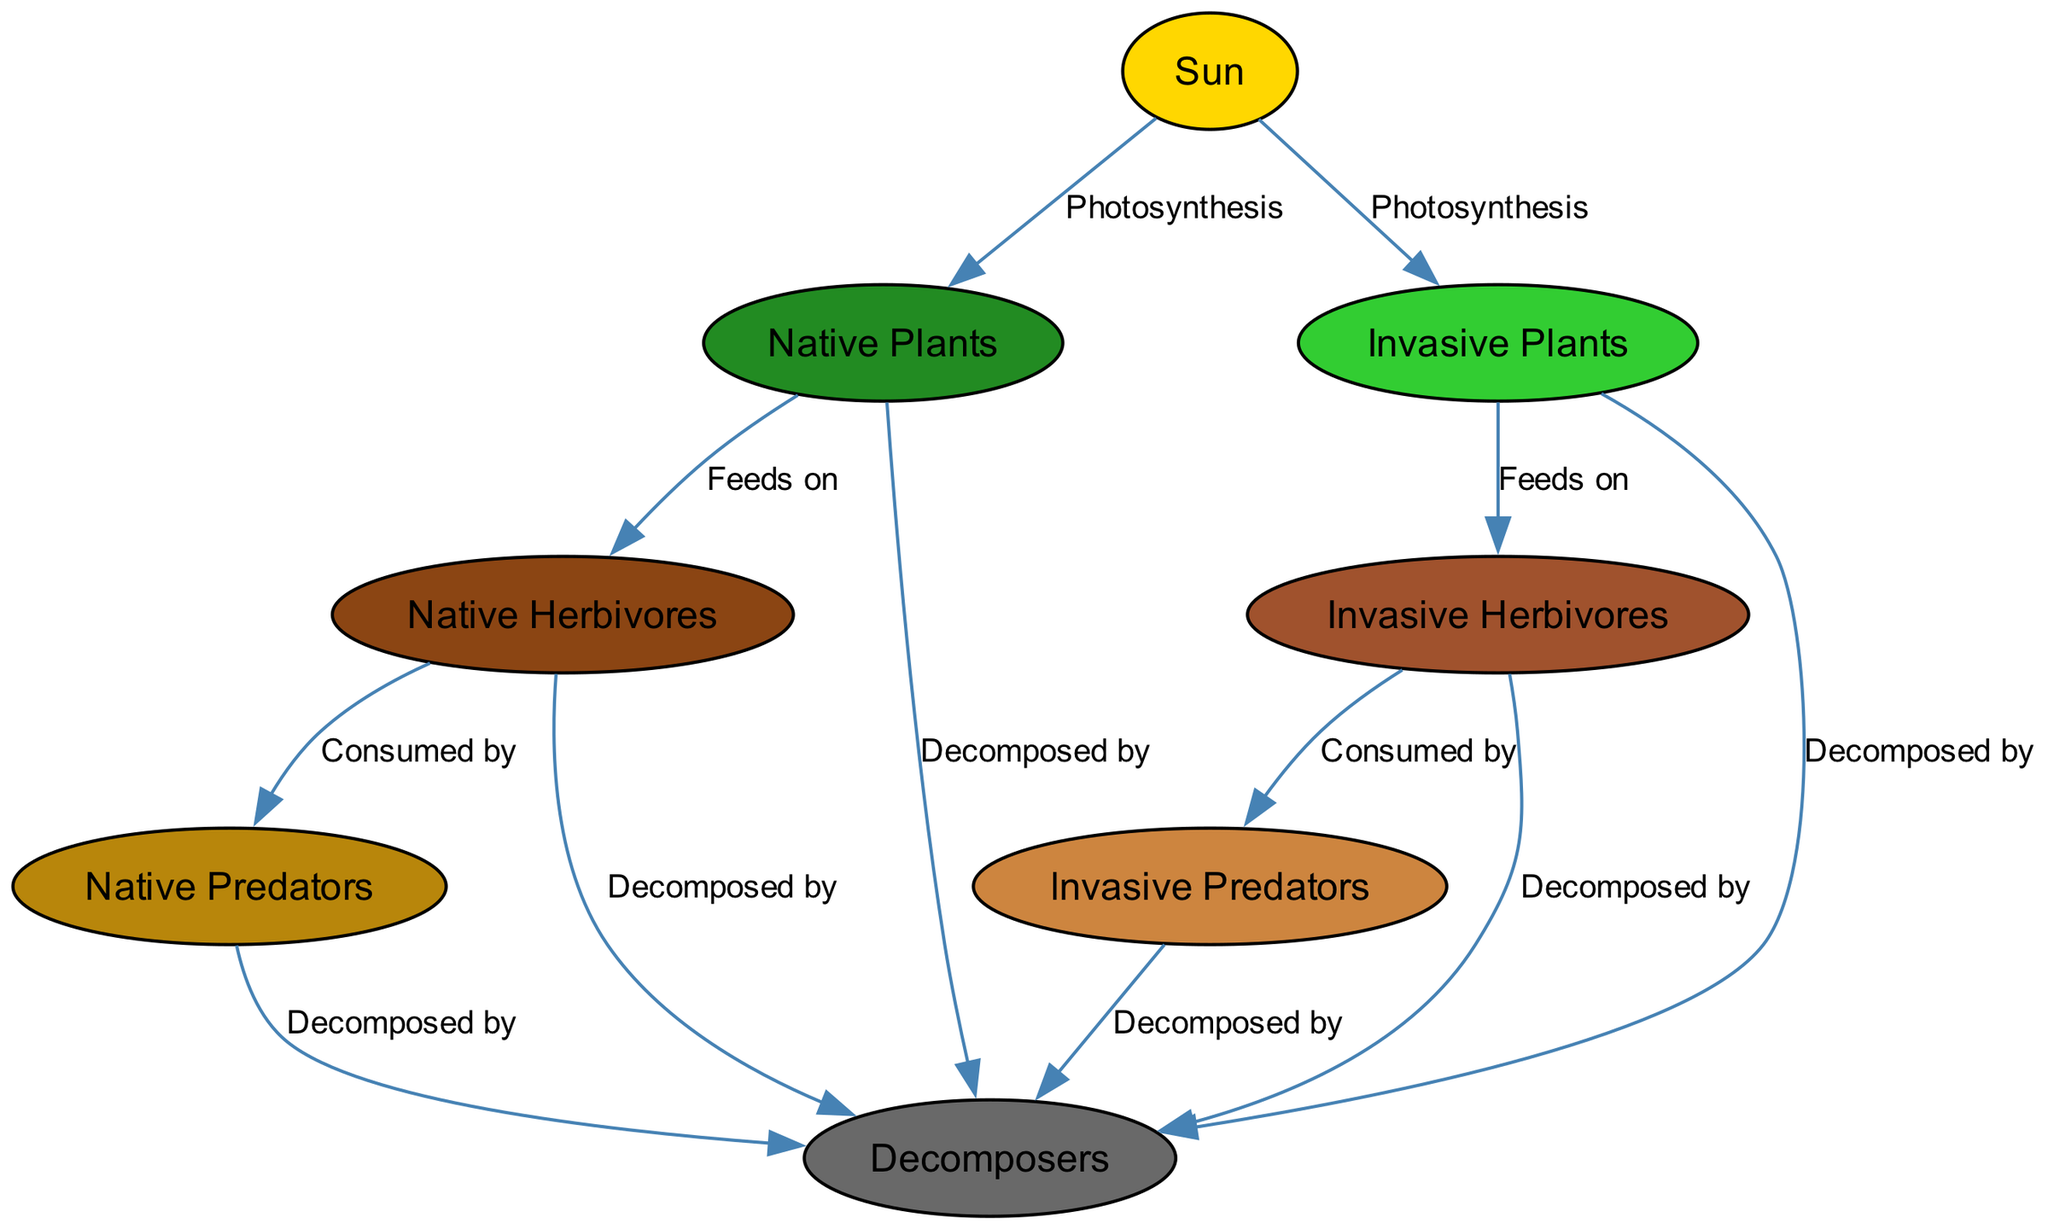What is the primary energy source in the Rock Creek Park ecosystem? The diagram shows an arrow pointing from the "Sun" node to both "Native Plants" and "Invasive Plants" nodes, indicating that the sun is the primary energy source for these plants through the process of photosynthesis.
Answer: Sun How many native herbivores are in the diagram? The diagram directly includes a single node labeled "Native Herbivores," indicating that there is one representation of native herbivores in the food chain.
Answer: 1 Which type of decomposers are shown consuming native predators? The diagram describes a flow with an arrow leading from "Native Predators" to "Decomposers," showing that decomposers are associated with dead organic material from native predators.
Answer: Decomposers What relationship is shown between invasive plants and invasive herbivores? The diagram indicates a flowing arrow from "Invasive Plants" to "Invasive Herbivores" labeled "Feeds on," showing that invasive herbivores consume invasive plants in this ecosystem.
Answer: Feeds on How many edges connect the herbivores to decomposers in the diagram? The diagram presents several arrows indicating relationships: one arrow from "Herbivores" to "Decomposers" and another from "Invasive Herbivores" to "Decomposers." Adding these, we find there are two edges connecting herbivores to decomposers.
Answer: 2 What would happen to the population of native predators if invasive herbivores increase? Given that "Invasive Herbivores" feed on "Invasive Plants," while "Native Herbivores" feed on "Native Plants," an increase in invasive herbivores may lead to a decrease in native herbivores, subsequently impacting the food supply for native predators.
Answer: Decrease Which two groups are affected by both native and invasive plants? The diagram shows that both "Native Herbivores" derive their food from "Native Plants," while "Invasive Herbivores" derive their food from "Invasive Plants." Therefore, both groups (herbivores) are affected by their respective plant types.
Answer: Native Herbivores, Invasive Herbivores What distinguishes the flow of energy between native and invasive species in the diagram? The diagram highlights separate paths where energy flows to native herbivores from native plants, while invasive herbivores and plants have their independent flows. This distinction illustrates how native and invasive species interact differently within the ecosystem.
Answer: Separate paths 